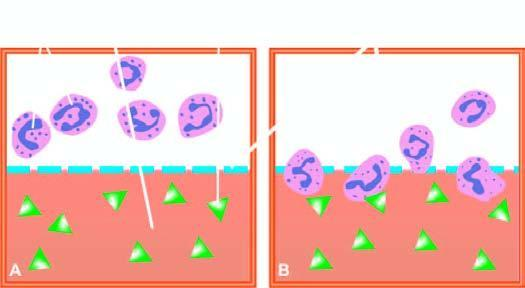what shows migration of neutrophils towards chemotactic agent?
Answer the question using a single word or phrase. Lower half of chamber 